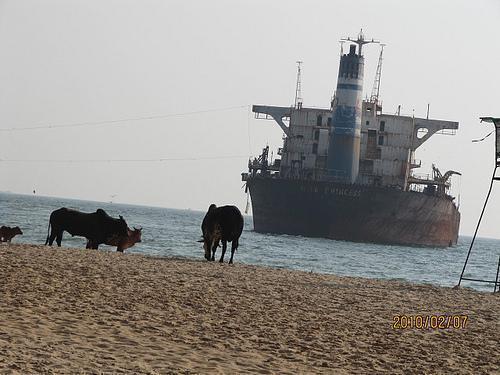How many cows are sniffing around on the beach front?
Select the correct answer and articulate reasoning with the following format: 'Answer: answer
Rationale: rationale.'
Options: Two, three, one, four. Answer: four.
Rationale: There are four cows. What is visible in the water?
From the following set of four choices, select the accurate answer to respond to the question.
Options: Snake, eel, boat, fish. Boat. 